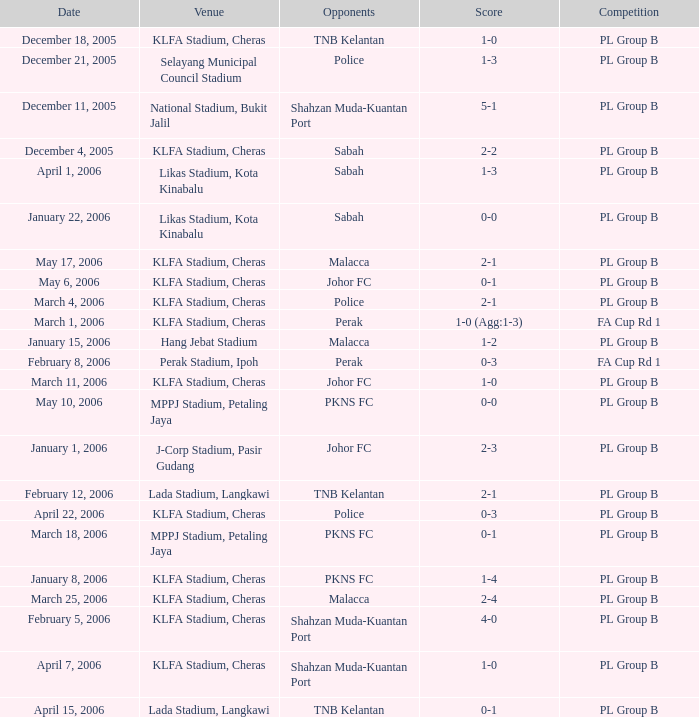What score did pkns fc's rivals have on january 8, 2006? 1-4. 